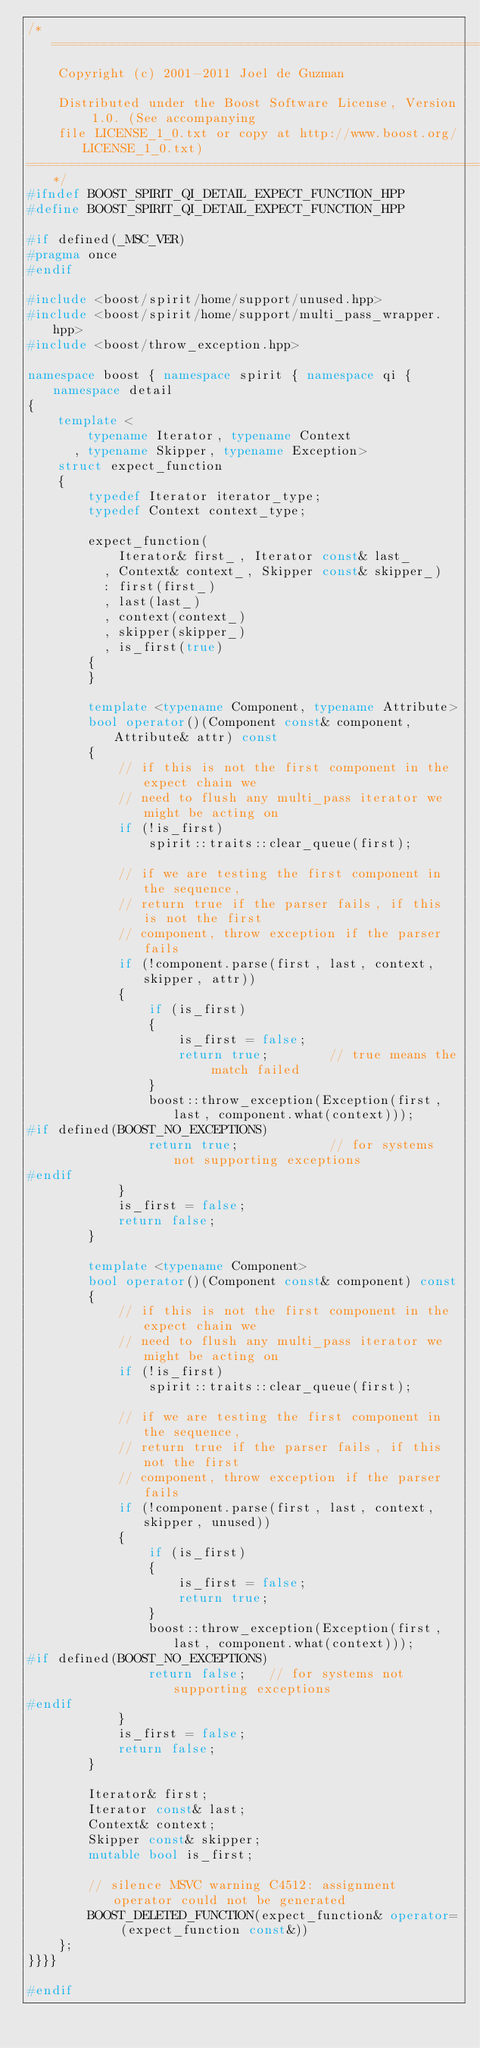<code> <loc_0><loc_0><loc_500><loc_500><_C++_>/*=============================================================================
    Copyright (c) 2001-2011 Joel de Guzman

    Distributed under the Boost Software License, Version 1.0. (See accompanying
    file LICENSE_1_0.txt or copy at http://www.boost.org/LICENSE_1_0.txt)
=============================================================================*/
#ifndef BOOST_SPIRIT_QI_DETAIL_EXPECT_FUNCTION_HPP
#define BOOST_SPIRIT_QI_DETAIL_EXPECT_FUNCTION_HPP

#if defined(_MSC_VER)
#pragma once
#endif

#include <boost/spirit/home/support/unused.hpp>
#include <boost/spirit/home/support/multi_pass_wrapper.hpp>
#include <boost/throw_exception.hpp>

namespace boost { namespace spirit { namespace qi { namespace detail
{
    template <
        typename Iterator, typename Context
      , typename Skipper, typename Exception>
    struct expect_function
    {
        typedef Iterator iterator_type;
        typedef Context context_type;

        expect_function(
            Iterator& first_, Iterator const& last_
          , Context& context_, Skipper const& skipper_)
          : first(first_)
          , last(last_)
          , context(context_)
          , skipper(skipper_)
          , is_first(true)
        {
        }

        template <typename Component, typename Attribute>
        bool operator()(Component const& component, Attribute& attr) const
        {
            // if this is not the first component in the expect chain we 
            // need to flush any multi_pass iterator we might be acting on
            if (!is_first)
                spirit::traits::clear_queue(first);

            // if we are testing the first component in the sequence,
            // return true if the parser fails, if this is not the first
            // component, throw exception if the parser fails
            if (!component.parse(first, last, context, skipper, attr))
            {
                if (is_first)
                {
                    is_first = false;
                    return true;        // true means the match failed
                }
                boost::throw_exception(Exception(first, last, component.what(context)));
#if defined(BOOST_NO_EXCEPTIONS)
                return true;            // for systems not supporting exceptions
#endif
            }
            is_first = false;
            return false;
        }

        template <typename Component>
        bool operator()(Component const& component) const
        {
            // if this is not the first component in the expect chain we 
            // need to flush any multi_pass iterator we might be acting on
            if (!is_first)
                spirit::traits::clear_queue(first);

            // if we are testing the first component in the sequence,
            // return true if the parser fails, if this not the first
            // component, throw exception if the parser fails
            if (!component.parse(first, last, context, skipper, unused))
            {
                if (is_first)
                {
                    is_first = false;
                    return true;
                }
                boost::throw_exception(Exception(first, last, component.what(context)));
#if defined(BOOST_NO_EXCEPTIONS)
                return false;   // for systems not supporting exceptions
#endif
            }
            is_first = false;
            return false;
        }

        Iterator& first;
        Iterator const& last;
        Context& context;
        Skipper const& skipper;
        mutable bool is_first;

        // silence MSVC warning C4512: assignment operator could not be generated
        BOOST_DELETED_FUNCTION(expect_function& operator= (expect_function const&))
    };
}}}}

#endif
</code> 